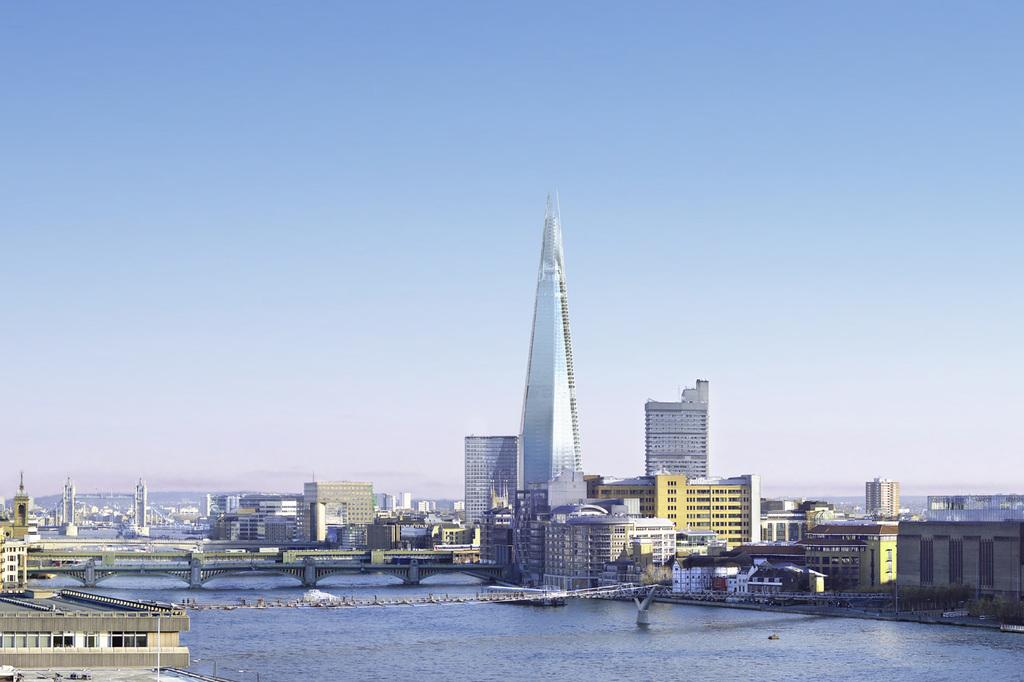What natural element can be seen in the image? There is water visible in the image. What type of structures are present in the image? There are bridges and buildings in the image. What is visible in the background of the image? The sky is visible in the background of the image. How many cups of tea are being served to the family in the image? There is no family or cups of tea present in the image. What type of creature is swimming in the water in the image? There is no creature visible in the water in the image. 